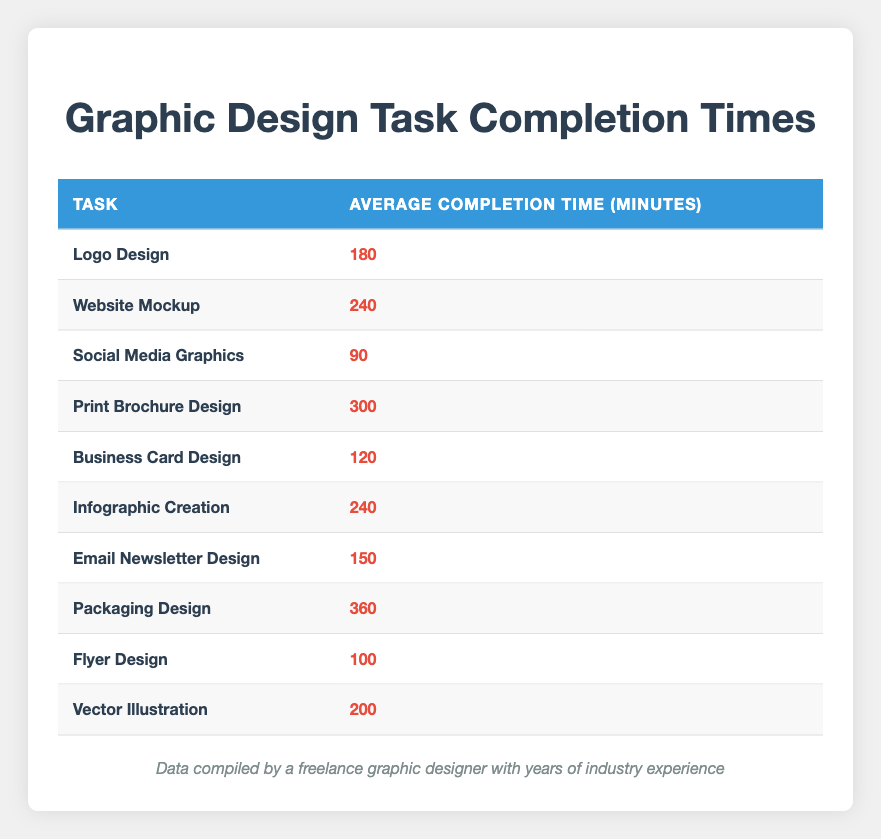What is the average completion time for Social Media Graphics? The average completion time listed for Social Media Graphics in the table is 90 minutes.
Answer: 90 minutes Which graphic design task takes the longest to complete? The longest average completion time is for Packaging Design, which is 360 minutes.
Answer: Packaging Design What is the average completion time for Print Brochure Design and Website Mockup combined? First, we find the average completion times: Print Brochure Design is 300 minutes and Website Mockup is 240 minutes. Summing these gives 300 + 240 = 540 minutes. To find the average of these two tasks, we divide by 2: 540 / 2 = 270 minutes.
Answer: 270 minutes Is the average completion time for Vector Illustration greater than or equal to 200 minutes? The average completion time for Vector Illustration is exactly 200 minutes, which meets the criterion of being greater than or equal to 200 minutes.
Answer: Yes What is the difference in average completion time between the longest task and the shortest task? The longest task is Packaging Design at 360 minutes, and the shortest task is Social Media Graphics at 90 minutes. The difference is calculated by subtracting the shorter time from the longer time: 360 - 90 = 270 minutes.
Answer: 270 minutes How many tasks have an average completion time of 240 minutes? There are two tasks in the table with an average completion time of 240 minutes: Website Mockup and Infographic Creation.
Answer: 2 tasks What is the average completion time of Email Newsletter Design? The average completion time for Email Newsletter Design in the table is 150 minutes.
Answer: 150 minutes Do more tasks require less than 150 minutes to complete compared to those that require more than 150 minutes? Checking the table, the tasks that require less than 150 minutes are Social Media Graphics (90), Business Card Design (120), and Flyer Design (100), totaling 3 tasks. The tasks requiring more than 150 minutes are Logo Design (180), Website Mockup (240), Print Brochure Design (300), Infographic Creation (240), Email Newsletter Design (150), Packaging Design (360), and Vector Illustration (200), totaling 7 tasks. So, there are more tasks that require more than 150 minutes.
Answer: No What is the combined average completion time for the tasks that take less than 200 minutes? The tasks that take less than 200 minutes are Social Media Graphics (90), Business Card Design (120), Email Newsletter Design (150), and Flyer Design (100). First, we sum these times: 90 + 120 + 150 + 100 = 460 minutes. Then, we divide by the number of tasks, which is 4: 460 / 4 = 115 minutes.
Answer: 115 minutes 